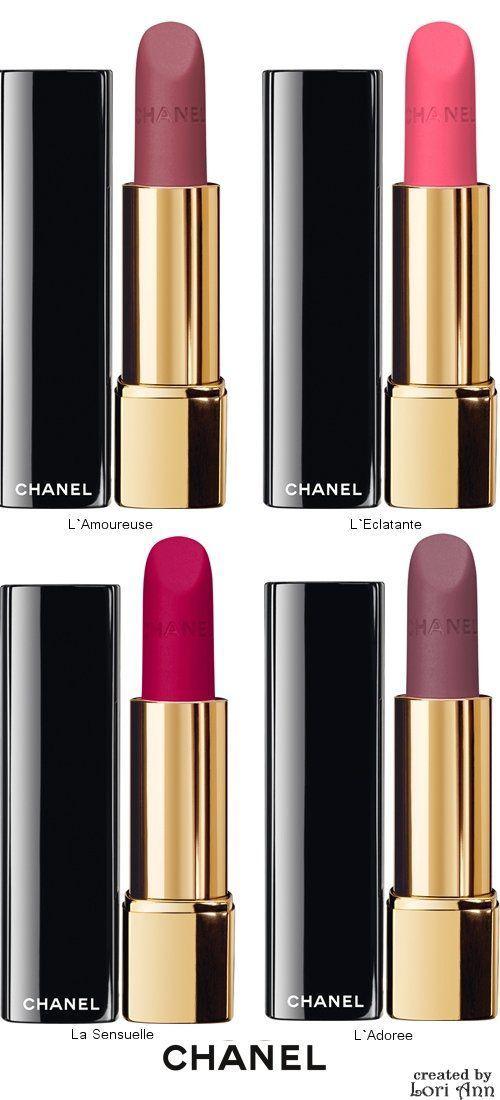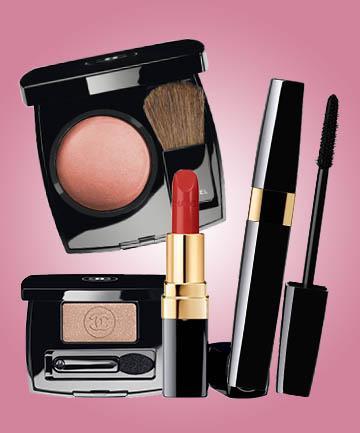The first image is the image on the left, the second image is the image on the right. Given the left and right images, does the statement "There are no more than four lipsticks in the image on the left." hold true? Answer yes or no. Yes. The first image is the image on the left, the second image is the image on the right. Considering the images on both sides, is "The left image shows at least four traditional lipsticks." valid? Answer yes or no. Yes. 